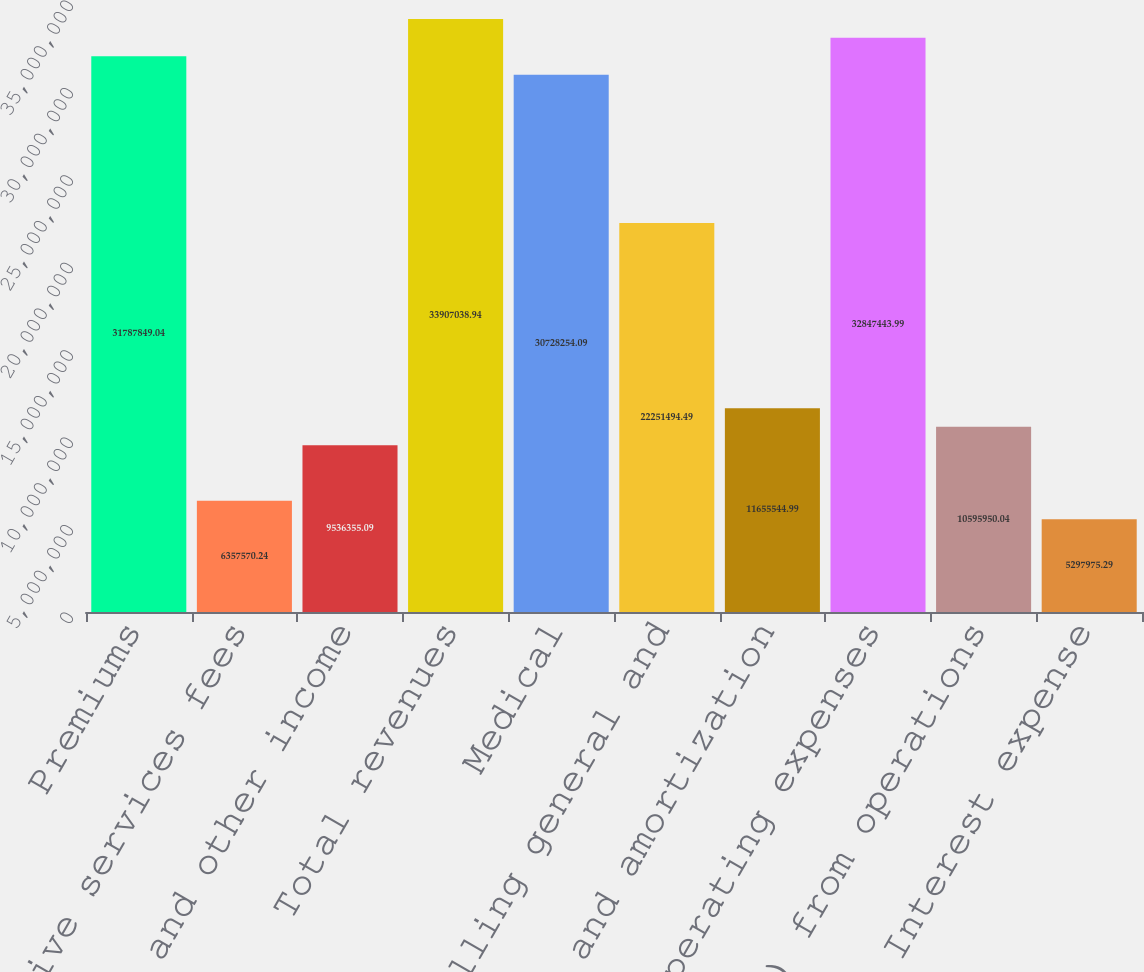<chart> <loc_0><loc_0><loc_500><loc_500><bar_chart><fcel>Premiums<fcel>Administrative services fees<fcel>Investment and other income<fcel>Total revenues<fcel>Medical<fcel>Selling general and<fcel>Depreciation and amortization<fcel>Total operating expenses<fcel>Income (loss) from operations<fcel>Interest expense<nl><fcel>3.17878e+07<fcel>6.35757e+06<fcel>9.53636e+06<fcel>3.3907e+07<fcel>3.07283e+07<fcel>2.22515e+07<fcel>1.16555e+07<fcel>3.28474e+07<fcel>1.0596e+07<fcel>5.29798e+06<nl></chart> 